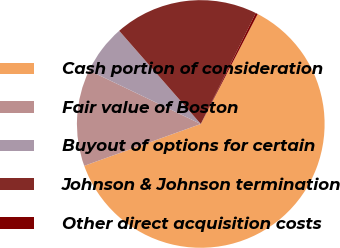Convert chart. <chart><loc_0><loc_0><loc_500><loc_500><pie_chart><fcel>Cash portion of consideration<fcel>Fair value of Boston<fcel>Buyout of options for certain<fcel>Johnson & Johnson termination<fcel>Other direct acquisition costs<nl><fcel>61.91%<fcel>12.6%<fcel>6.44%<fcel>18.77%<fcel>0.28%<nl></chart> 